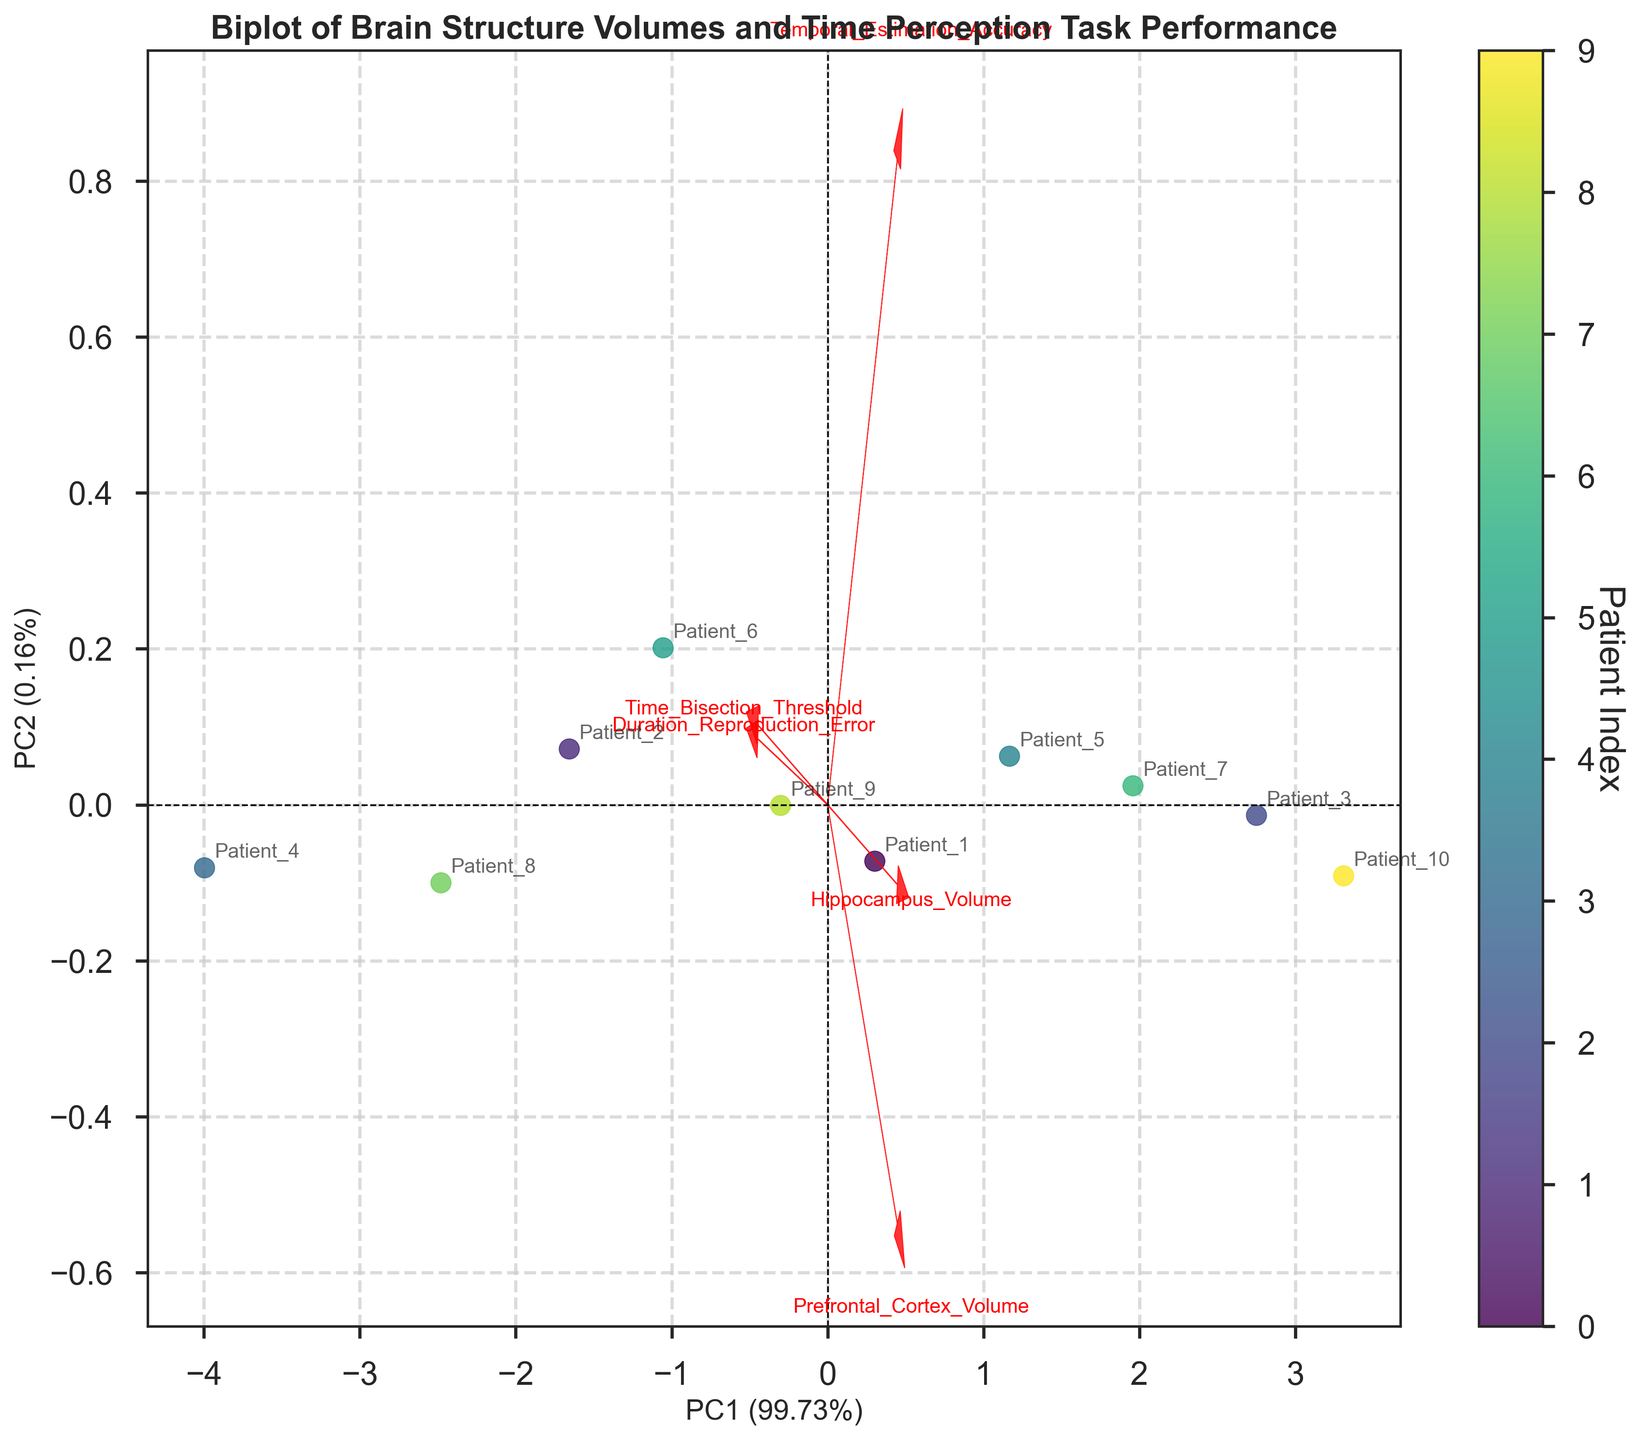What is the title of the plot? The title is usually located at the top of the plot and is in bold text in this plot. It indicates what the plot is representing.
Answer: Biplot of Brain Structure Volumes and Time Perception Task Performance What are the percentages explained by the first and second principal components? The explained variance percentages are displayed on the axes labels as part of the axis titles.
Answer: PC1 (72.43%) and PC2 (16.72%) How many patients' data points are represented in the plot? The data points are represented by scatter points in the biplot, each one corresponding to a patient. By counting these points, we get the answer.
Answer: 10 Which variable has the largest vector in the biplot, indicating it contributes most to the principal components? In a biplot, the length of the vector represents the contribution of that variable. The longest vector will tell us the most significant variable.
Answer: Prefrontal_Cortex_Volume Are there any variables that are closely aligned, suggesting they are highly correlated? Closely aligned vectors in the same direction indicate a high correlation. We look at the vectors' directions and their closeness to each other.
Answer: Hippocampus_Volume and Temporal_Estimation_Accuracy What is the relationship between Duration_Reproduction_Error and Time_Bisection_Threshold based on the biplot vectors? The relative angle between the vectors represents the correlation. If vectors are perpendicular, they are uncorrelated, whereas if they are in the same direction or opposite, they are positively or negatively correlated, respectively.
Answer: They are positively correlated Which patient has the highest PC1 score? The PC1 score can be seen along the x-axis. The patient represented by the data point farthest to the right will have the highest PC1 score.
Answer: Patient_10 How does the variability in Prefrontal_Cortex_Volume compare to Temporal_Estimation_Accuracy? The length of the vectors can be compared. Longer vectors indicate higher variability in that dimension.
Answer: Prefrontal_Cortex_Volume has more variability Which patients are closely clustered together, indicating similar profiles? Patients that are close to each other in the scatter plot suggest they have similar profiles as per the principal components.
Answer: Patient_1 and Patient_5 What does it mean if a patient's data point is far from the origin in the biplot? Distance from the origin indicates the level of variability. High-distance points represent patients that have extreme values in at least one of the measured variables. The farther a point is from the origin, the more distinct the patient's profile.
Answer: The patient has a unique profile with significant variation in at least one variable 